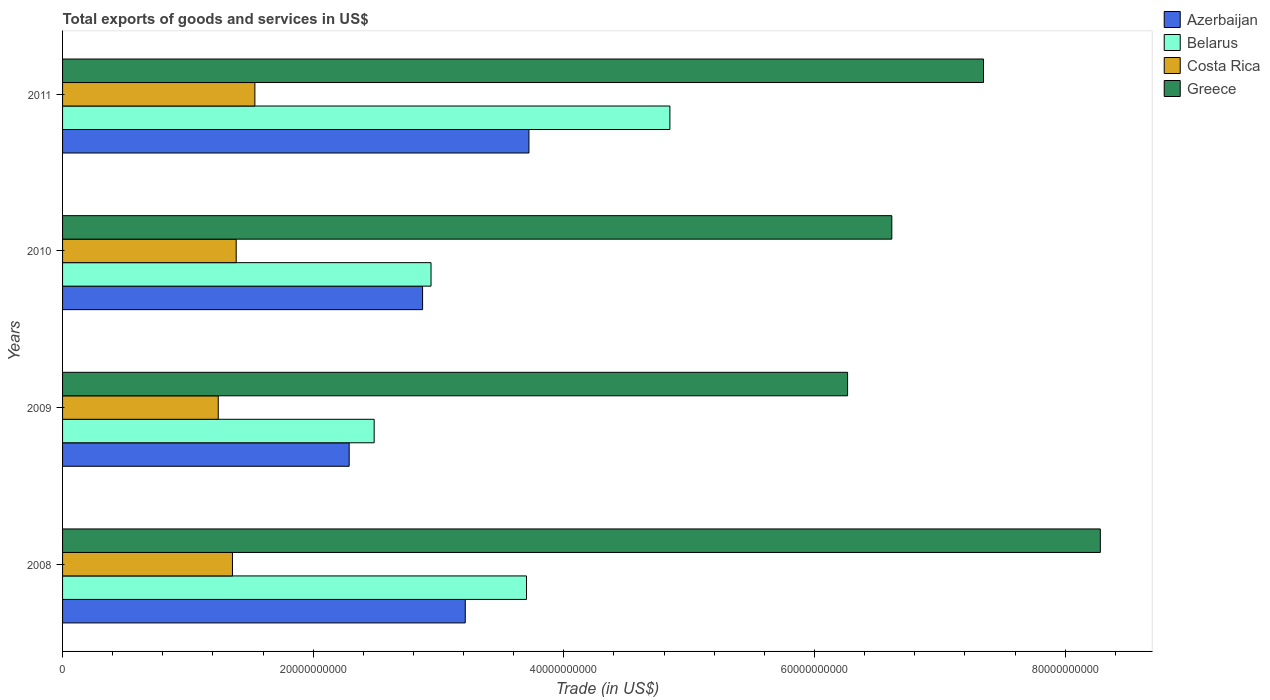How many different coloured bars are there?
Your response must be concise. 4. How many groups of bars are there?
Give a very brief answer. 4. Are the number of bars per tick equal to the number of legend labels?
Provide a succinct answer. Yes. Are the number of bars on each tick of the Y-axis equal?
Make the answer very short. Yes. What is the label of the 2nd group of bars from the top?
Make the answer very short. 2010. In how many cases, is the number of bars for a given year not equal to the number of legend labels?
Make the answer very short. 0. What is the total exports of goods and services in Greece in 2008?
Keep it short and to the point. 8.28e+1. Across all years, what is the maximum total exports of goods and services in Belarus?
Give a very brief answer. 4.85e+1. Across all years, what is the minimum total exports of goods and services in Costa Rica?
Keep it short and to the point. 1.24e+1. In which year was the total exports of goods and services in Greece maximum?
Give a very brief answer. 2008. In which year was the total exports of goods and services in Greece minimum?
Your response must be concise. 2009. What is the total total exports of goods and services in Costa Rica in the graph?
Your answer should be compact. 5.52e+1. What is the difference between the total exports of goods and services in Belarus in 2008 and that in 2010?
Ensure brevity in your answer.  7.62e+09. What is the difference between the total exports of goods and services in Azerbaijan in 2010 and the total exports of goods and services in Belarus in 2009?
Ensure brevity in your answer.  3.86e+09. What is the average total exports of goods and services in Azerbaijan per year?
Your answer should be compact. 3.02e+1. In the year 2011, what is the difference between the total exports of goods and services in Costa Rica and total exports of goods and services in Greece?
Provide a short and direct response. -5.81e+1. In how many years, is the total exports of goods and services in Costa Rica greater than 52000000000 US$?
Your response must be concise. 0. What is the ratio of the total exports of goods and services in Greece in 2009 to that in 2011?
Provide a succinct answer. 0.85. Is the total exports of goods and services in Azerbaijan in 2008 less than that in 2009?
Ensure brevity in your answer.  No. Is the difference between the total exports of goods and services in Costa Rica in 2009 and 2011 greater than the difference between the total exports of goods and services in Greece in 2009 and 2011?
Your response must be concise. Yes. What is the difference between the highest and the second highest total exports of goods and services in Belarus?
Make the answer very short. 1.14e+1. What is the difference between the highest and the lowest total exports of goods and services in Azerbaijan?
Your response must be concise. 1.43e+1. In how many years, is the total exports of goods and services in Greece greater than the average total exports of goods and services in Greece taken over all years?
Your answer should be very brief. 2. What does the 3rd bar from the top in 2008 represents?
Your response must be concise. Belarus. What does the 1st bar from the bottom in 2009 represents?
Your answer should be compact. Azerbaijan. Are all the bars in the graph horizontal?
Your response must be concise. Yes. How many years are there in the graph?
Offer a very short reply. 4. What is the difference between two consecutive major ticks on the X-axis?
Your answer should be very brief. 2.00e+1. How many legend labels are there?
Make the answer very short. 4. How are the legend labels stacked?
Provide a short and direct response. Vertical. What is the title of the graph?
Provide a short and direct response. Total exports of goods and services in US$. Does "Lesotho" appear as one of the legend labels in the graph?
Offer a very short reply. No. What is the label or title of the X-axis?
Your answer should be very brief. Trade (in US$). What is the Trade (in US$) in Azerbaijan in 2008?
Your answer should be compact. 3.21e+1. What is the Trade (in US$) of Belarus in 2008?
Your answer should be very brief. 3.70e+1. What is the Trade (in US$) of Costa Rica in 2008?
Your response must be concise. 1.36e+1. What is the Trade (in US$) of Greece in 2008?
Ensure brevity in your answer.  8.28e+1. What is the Trade (in US$) of Azerbaijan in 2009?
Give a very brief answer. 2.29e+1. What is the Trade (in US$) of Belarus in 2009?
Your answer should be very brief. 2.49e+1. What is the Trade (in US$) of Costa Rica in 2009?
Provide a succinct answer. 1.24e+1. What is the Trade (in US$) of Greece in 2009?
Ensure brevity in your answer.  6.26e+1. What is the Trade (in US$) of Azerbaijan in 2010?
Ensure brevity in your answer.  2.87e+1. What is the Trade (in US$) in Belarus in 2010?
Keep it short and to the point. 2.94e+1. What is the Trade (in US$) in Costa Rica in 2010?
Keep it short and to the point. 1.39e+1. What is the Trade (in US$) of Greece in 2010?
Offer a very short reply. 6.62e+1. What is the Trade (in US$) in Azerbaijan in 2011?
Make the answer very short. 3.72e+1. What is the Trade (in US$) in Belarus in 2011?
Keep it short and to the point. 4.85e+1. What is the Trade (in US$) of Costa Rica in 2011?
Provide a succinct answer. 1.53e+1. What is the Trade (in US$) of Greece in 2011?
Give a very brief answer. 7.35e+1. Across all years, what is the maximum Trade (in US$) in Azerbaijan?
Make the answer very short. 3.72e+1. Across all years, what is the maximum Trade (in US$) in Belarus?
Provide a succinct answer. 4.85e+1. Across all years, what is the maximum Trade (in US$) in Costa Rica?
Your answer should be very brief. 1.53e+1. Across all years, what is the maximum Trade (in US$) in Greece?
Your answer should be compact. 8.28e+1. Across all years, what is the minimum Trade (in US$) of Azerbaijan?
Provide a short and direct response. 2.29e+1. Across all years, what is the minimum Trade (in US$) of Belarus?
Offer a very short reply. 2.49e+1. Across all years, what is the minimum Trade (in US$) in Costa Rica?
Provide a short and direct response. 1.24e+1. Across all years, what is the minimum Trade (in US$) in Greece?
Your response must be concise. 6.26e+1. What is the total Trade (in US$) in Azerbaijan in the graph?
Offer a terse response. 1.21e+11. What is the total Trade (in US$) of Belarus in the graph?
Your answer should be very brief. 1.40e+11. What is the total Trade (in US$) in Costa Rica in the graph?
Your response must be concise. 5.52e+1. What is the total Trade (in US$) of Greece in the graph?
Give a very brief answer. 2.85e+11. What is the difference between the Trade (in US$) of Azerbaijan in 2008 and that in 2009?
Offer a terse response. 9.26e+09. What is the difference between the Trade (in US$) of Belarus in 2008 and that in 2009?
Provide a short and direct response. 1.22e+1. What is the difference between the Trade (in US$) of Costa Rica in 2008 and that in 2009?
Your response must be concise. 1.13e+09. What is the difference between the Trade (in US$) of Greece in 2008 and that in 2009?
Your answer should be compact. 2.02e+1. What is the difference between the Trade (in US$) in Azerbaijan in 2008 and that in 2010?
Your response must be concise. 3.40e+09. What is the difference between the Trade (in US$) of Belarus in 2008 and that in 2010?
Provide a short and direct response. 7.62e+09. What is the difference between the Trade (in US$) in Costa Rica in 2008 and that in 2010?
Provide a succinct answer. -2.98e+08. What is the difference between the Trade (in US$) of Greece in 2008 and that in 2010?
Provide a succinct answer. 1.66e+1. What is the difference between the Trade (in US$) in Azerbaijan in 2008 and that in 2011?
Keep it short and to the point. -5.08e+09. What is the difference between the Trade (in US$) in Belarus in 2008 and that in 2011?
Provide a short and direct response. -1.14e+1. What is the difference between the Trade (in US$) in Costa Rica in 2008 and that in 2011?
Your answer should be very brief. -1.79e+09. What is the difference between the Trade (in US$) in Greece in 2008 and that in 2011?
Offer a very short reply. 9.32e+09. What is the difference between the Trade (in US$) in Azerbaijan in 2009 and that in 2010?
Your response must be concise. -5.86e+09. What is the difference between the Trade (in US$) in Belarus in 2009 and that in 2010?
Provide a succinct answer. -4.54e+09. What is the difference between the Trade (in US$) in Costa Rica in 2009 and that in 2010?
Offer a very short reply. -1.43e+09. What is the difference between the Trade (in US$) of Greece in 2009 and that in 2010?
Your answer should be compact. -3.53e+09. What is the difference between the Trade (in US$) of Azerbaijan in 2009 and that in 2011?
Keep it short and to the point. -1.43e+1. What is the difference between the Trade (in US$) in Belarus in 2009 and that in 2011?
Ensure brevity in your answer.  -2.36e+1. What is the difference between the Trade (in US$) in Costa Rica in 2009 and that in 2011?
Your response must be concise. -2.92e+09. What is the difference between the Trade (in US$) of Greece in 2009 and that in 2011?
Your answer should be compact. -1.08e+1. What is the difference between the Trade (in US$) in Azerbaijan in 2010 and that in 2011?
Provide a succinct answer. -8.49e+09. What is the difference between the Trade (in US$) of Belarus in 2010 and that in 2011?
Make the answer very short. -1.91e+1. What is the difference between the Trade (in US$) in Costa Rica in 2010 and that in 2011?
Keep it short and to the point. -1.49e+09. What is the difference between the Trade (in US$) of Greece in 2010 and that in 2011?
Your response must be concise. -7.32e+09. What is the difference between the Trade (in US$) in Azerbaijan in 2008 and the Trade (in US$) in Belarus in 2009?
Ensure brevity in your answer.  7.27e+09. What is the difference between the Trade (in US$) of Azerbaijan in 2008 and the Trade (in US$) of Costa Rica in 2009?
Make the answer very short. 1.97e+1. What is the difference between the Trade (in US$) of Azerbaijan in 2008 and the Trade (in US$) of Greece in 2009?
Ensure brevity in your answer.  -3.05e+1. What is the difference between the Trade (in US$) in Belarus in 2008 and the Trade (in US$) in Costa Rica in 2009?
Your answer should be compact. 2.46e+1. What is the difference between the Trade (in US$) of Belarus in 2008 and the Trade (in US$) of Greece in 2009?
Make the answer very short. -2.56e+1. What is the difference between the Trade (in US$) in Costa Rica in 2008 and the Trade (in US$) in Greece in 2009?
Offer a very short reply. -4.91e+1. What is the difference between the Trade (in US$) of Azerbaijan in 2008 and the Trade (in US$) of Belarus in 2010?
Provide a succinct answer. 2.73e+09. What is the difference between the Trade (in US$) in Azerbaijan in 2008 and the Trade (in US$) in Costa Rica in 2010?
Offer a terse response. 1.83e+1. What is the difference between the Trade (in US$) of Azerbaijan in 2008 and the Trade (in US$) of Greece in 2010?
Make the answer very short. -3.40e+1. What is the difference between the Trade (in US$) of Belarus in 2008 and the Trade (in US$) of Costa Rica in 2010?
Give a very brief answer. 2.32e+1. What is the difference between the Trade (in US$) in Belarus in 2008 and the Trade (in US$) in Greece in 2010?
Provide a succinct answer. -2.91e+1. What is the difference between the Trade (in US$) of Costa Rica in 2008 and the Trade (in US$) of Greece in 2010?
Your answer should be compact. -5.26e+1. What is the difference between the Trade (in US$) of Azerbaijan in 2008 and the Trade (in US$) of Belarus in 2011?
Keep it short and to the point. -1.63e+1. What is the difference between the Trade (in US$) of Azerbaijan in 2008 and the Trade (in US$) of Costa Rica in 2011?
Make the answer very short. 1.68e+1. What is the difference between the Trade (in US$) in Azerbaijan in 2008 and the Trade (in US$) in Greece in 2011?
Provide a short and direct response. -4.14e+1. What is the difference between the Trade (in US$) in Belarus in 2008 and the Trade (in US$) in Costa Rica in 2011?
Your answer should be compact. 2.17e+1. What is the difference between the Trade (in US$) in Belarus in 2008 and the Trade (in US$) in Greece in 2011?
Ensure brevity in your answer.  -3.65e+1. What is the difference between the Trade (in US$) in Costa Rica in 2008 and the Trade (in US$) in Greece in 2011?
Provide a succinct answer. -5.99e+1. What is the difference between the Trade (in US$) of Azerbaijan in 2009 and the Trade (in US$) of Belarus in 2010?
Your answer should be very brief. -6.53e+09. What is the difference between the Trade (in US$) of Azerbaijan in 2009 and the Trade (in US$) of Costa Rica in 2010?
Keep it short and to the point. 9.02e+09. What is the difference between the Trade (in US$) of Azerbaijan in 2009 and the Trade (in US$) of Greece in 2010?
Make the answer very short. -4.33e+1. What is the difference between the Trade (in US$) in Belarus in 2009 and the Trade (in US$) in Costa Rica in 2010?
Your answer should be very brief. 1.10e+1. What is the difference between the Trade (in US$) in Belarus in 2009 and the Trade (in US$) in Greece in 2010?
Keep it short and to the point. -4.13e+1. What is the difference between the Trade (in US$) in Costa Rica in 2009 and the Trade (in US$) in Greece in 2010?
Keep it short and to the point. -5.37e+1. What is the difference between the Trade (in US$) of Azerbaijan in 2009 and the Trade (in US$) of Belarus in 2011?
Make the answer very short. -2.56e+1. What is the difference between the Trade (in US$) of Azerbaijan in 2009 and the Trade (in US$) of Costa Rica in 2011?
Offer a very short reply. 7.53e+09. What is the difference between the Trade (in US$) of Azerbaijan in 2009 and the Trade (in US$) of Greece in 2011?
Make the answer very short. -5.06e+1. What is the difference between the Trade (in US$) of Belarus in 2009 and the Trade (in US$) of Costa Rica in 2011?
Provide a succinct answer. 9.52e+09. What is the difference between the Trade (in US$) in Belarus in 2009 and the Trade (in US$) in Greece in 2011?
Give a very brief answer. -4.86e+1. What is the difference between the Trade (in US$) of Costa Rica in 2009 and the Trade (in US$) of Greece in 2011?
Your answer should be compact. -6.11e+1. What is the difference between the Trade (in US$) of Azerbaijan in 2010 and the Trade (in US$) of Belarus in 2011?
Keep it short and to the point. -1.97e+1. What is the difference between the Trade (in US$) in Azerbaijan in 2010 and the Trade (in US$) in Costa Rica in 2011?
Keep it short and to the point. 1.34e+1. What is the difference between the Trade (in US$) in Azerbaijan in 2010 and the Trade (in US$) in Greece in 2011?
Give a very brief answer. -4.48e+1. What is the difference between the Trade (in US$) in Belarus in 2010 and the Trade (in US$) in Costa Rica in 2011?
Give a very brief answer. 1.41e+1. What is the difference between the Trade (in US$) in Belarus in 2010 and the Trade (in US$) in Greece in 2011?
Offer a very short reply. -4.41e+1. What is the difference between the Trade (in US$) of Costa Rica in 2010 and the Trade (in US$) of Greece in 2011?
Offer a very short reply. -5.96e+1. What is the average Trade (in US$) in Azerbaijan per year?
Your response must be concise. 3.02e+1. What is the average Trade (in US$) of Belarus per year?
Your answer should be compact. 3.49e+1. What is the average Trade (in US$) in Costa Rica per year?
Keep it short and to the point. 1.38e+1. What is the average Trade (in US$) of Greece per year?
Keep it short and to the point. 7.13e+1. In the year 2008, what is the difference between the Trade (in US$) of Azerbaijan and Trade (in US$) of Belarus?
Ensure brevity in your answer.  -4.89e+09. In the year 2008, what is the difference between the Trade (in US$) of Azerbaijan and Trade (in US$) of Costa Rica?
Ensure brevity in your answer.  1.86e+1. In the year 2008, what is the difference between the Trade (in US$) of Azerbaijan and Trade (in US$) of Greece?
Provide a short and direct response. -5.07e+1. In the year 2008, what is the difference between the Trade (in US$) in Belarus and Trade (in US$) in Costa Rica?
Your answer should be compact. 2.35e+1. In the year 2008, what is the difference between the Trade (in US$) in Belarus and Trade (in US$) in Greece?
Your response must be concise. -4.58e+1. In the year 2008, what is the difference between the Trade (in US$) in Costa Rica and Trade (in US$) in Greece?
Offer a terse response. -6.93e+1. In the year 2009, what is the difference between the Trade (in US$) of Azerbaijan and Trade (in US$) of Belarus?
Make the answer very short. -1.99e+09. In the year 2009, what is the difference between the Trade (in US$) in Azerbaijan and Trade (in US$) in Costa Rica?
Your response must be concise. 1.04e+1. In the year 2009, what is the difference between the Trade (in US$) in Azerbaijan and Trade (in US$) in Greece?
Offer a terse response. -3.98e+1. In the year 2009, what is the difference between the Trade (in US$) of Belarus and Trade (in US$) of Costa Rica?
Offer a very short reply. 1.24e+1. In the year 2009, what is the difference between the Trade (in US$) of Belarus and Trade (in US$) of Greece?
Provide a succinct answer. -3.78e+1. In the year 2009, what is the difference between the Trade (in US$) of Costa Rica and Trade (in US$) of Greece?
Offer a very short reply. -5.02e+1. In the year 2010, what is the difference between the Trade (in US$) in Azerbaijan and Trade (in US$) in Belarus?
Ensure brevity in your answer.  -6.73e+08. In the year 2010, what is the difference between the Trade (in US$) in Azerbaijan and Trade (in US$) in Costa Rica?
Offer a terse response. 1.49e+1. In the year 2010, what is the difference between the Trade (in US$) in Azerbaijan and Trade (in US$) in Greece?
Provide a succinct answer. -3.74e+1. In the year 2010, what is the difference between the Trade (in US$) of Belarus and Trade (in US$) of Costa Rica?
Provide a succinct answer. 1.55e+1. In the year 2010, what is the difference between the Trade (in US$) in Belarus and Trade (in US$) in Greece?
Provide a short and direct response. -3.68e+1. In the year 2010, what is the difference between the Trade (in US$) in Costa Rica and Trade (in US$) in Greece?
Provide a short and direct response. -5.23e+1. In the year 2011, what is the difference between the Trade (in US$) of Azerbaijan and Trade (in US$) of Belarus?
Offer a terse response. -1.12e+1. In the year 2011, what is the difference between the Trade (in US$) in Azerbaijan and Trade (in US$) in Costa Rica?
Give a very brief answer. 2.19e+1. In the year 2011, what is the difference between the Trade (in US$) of Azerbaijan and Trade (in US$) of Greece?
Provide a succinct answer. -3.63e+1. In the year 2011, what is the difference between the Trade (in US$) in Belarus and Trade (in US$) in Costa Rica?
Provide a succinct answer. 3.31e+1. In the year 2011, what is the difference between the Trade (in US$) in Belarus and Trade (in US$) in Greece?
Make the answer very short. -2.50e+1. In the year 2011, what is the difference between the Trade (in US$) of Costa Rica and Trade (in US$) of Greece?
Your answer should be compact. -5.81e+1. What is the ratio of the Trade (in US$) of Azerbaijan in 2008 to that in 2009?
Provide a succinct answer. 1.41. What is the ratio of the Trade (in US$) in Belarus in 2008 to that in 2009?
Your response must be concise. 1.49. What is the ratio of the Trade (in US$) in Costa Rica in 2008 to that in 2009?
Give a very brief answer. 1.09. What is the ratio of the Trade (in US$) of Greece in 2008 to that in 2009?
Keep it short and to the point. 1.32. What is the ratio of the Trade (in US$) of Azerbaijan in 2008 to that in 2010?
Offer a terse response. 1.12. What is the ratio of the Trade (in US$) in Belarus in 2008 to that in 2010?
Ensure brevity in your answer.  1.26. What is the ratio of the Trade (in US$) in Costa Rica in 2008 to that in 2010?
Ensure brevity in your answer.  0.98. What is the ratio of the Trade (in US$) of Greece in 2008 to that in 2010?
Keep it short and to the point. 1.25. What is the ratio of the Trade (in US$) in Azerbaijan in 2008 to that in 2011?
Offer a terse response. 0.86. What is the ratio of the Trade (in US$) in Belarus in 2008 to that in 2011?
Ensure brevity in your answer.  0.76. What is the ratio of the Trade (in US$) in Costa Rica in 2008 to that in 2011?
Provide a succinct answer. 0.88. What is the ratio of the Trade (in US$) in Greece in 2008 to that in 2011?
Give a very brief answer. 1.13. What is the ratio of the Trade (in US$) in Azerbaijan in 2009 to that in 2010?
Offer a very short reply. 0.8. What is the ratio of the Trade (in US$) in Belarus in 2009 to that in 2010?
Offer a terse response. 0.85. What is the ratio of the Trade (in US$) of Costa Rica in 2009 to that in 2010?
Provide a succinct answer. 0.9. What is the ratio of the Trade (in US$) of Greece in 2009 to that in 2010?
Your answer should be very brief. 0.95. What is the ratio of the Trade (in US$) in Azerbaijan in 2009 to that in 2011?
Give a very brief answer. 0.61. What is the ratio of the Trade (in US$) of Belarus in 2009 to that in 2011?
Provide a succinct answer. 0.51. What is the ratio of the Trade (in US$) of Costa Rica in 2009 to that in 2011?
Make the answer very short. 0.81. What is the ratio of the Trade (in US$) in Greece in 2009 to that in 2011?
Make the answer very short. 0.85. What is the ratio of the Trade (in US$) in Azerbaijan in 2010 to that in 2011?
Ensure brevity in your answer.  0.77. What is the ratio of the Trade (in US$) of Belarus in 2010 to that in 2011?
Give a very brief answer. 0.61. What is the ratio of the Trade (in US$) in Costa Rica in 2010 to that in 2011?
Provide a short and direct response. 0.9. What is the ratio of the Trade (in US$) in Greece in 2010 to that in 2011?
Provide a succinct answer. 0.9. What is the difference between the highest and the second highest Trade (in US$) of Azerbaijan?
Offer a very short reply. 5.08e+09. What is the difference between the highest and the second highest Trade (in US$) in Belarus?
Your answer should be very brief. 1.14e+1. What is the difference between the highest and the second highest Trade (in US$) of Costa Rica?
Your answer should be compact. 1.49e+09. What is the difference between the highest and the second highest Trade (in US$) of Greece?
Make the answer very short. 9.32e+09. What is the difference between the highest and the lowest Trade (in US$) in Azerbaijan?
Your response must be concise. 1.43e+1. What is the difference between the highest and the lowest Trade (in US$) in Belarus?
Offer a terse response. 2.36e+1. What is the difference between the highest and the lowest Trade (in US$) in Costa Rica?
Keep it short and to the point. 2.92e+09. What is the difference between the highest and the lowest Trade (in US$) in Greece?
Ensure brevity in your answer.  2.02e+1. 